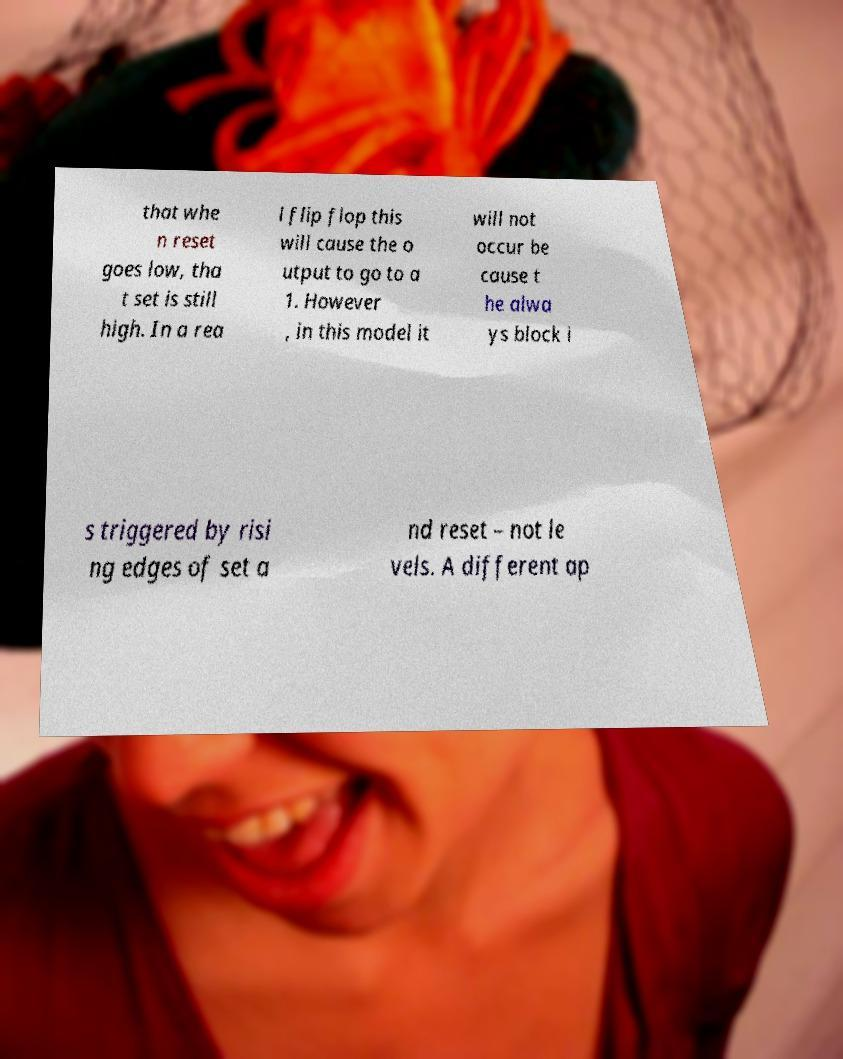For documentation purposes, I need the text within this image transcribed. Could you provide that? that whe n reset goes low, tha t set is still high. In a rea l flip flop this will cause the o utput to go to a 1. However , in this model it will not occur be cause t he alwa ys block i s triggered by risi ng edges of set a nd reset – not le vels. A different ap 